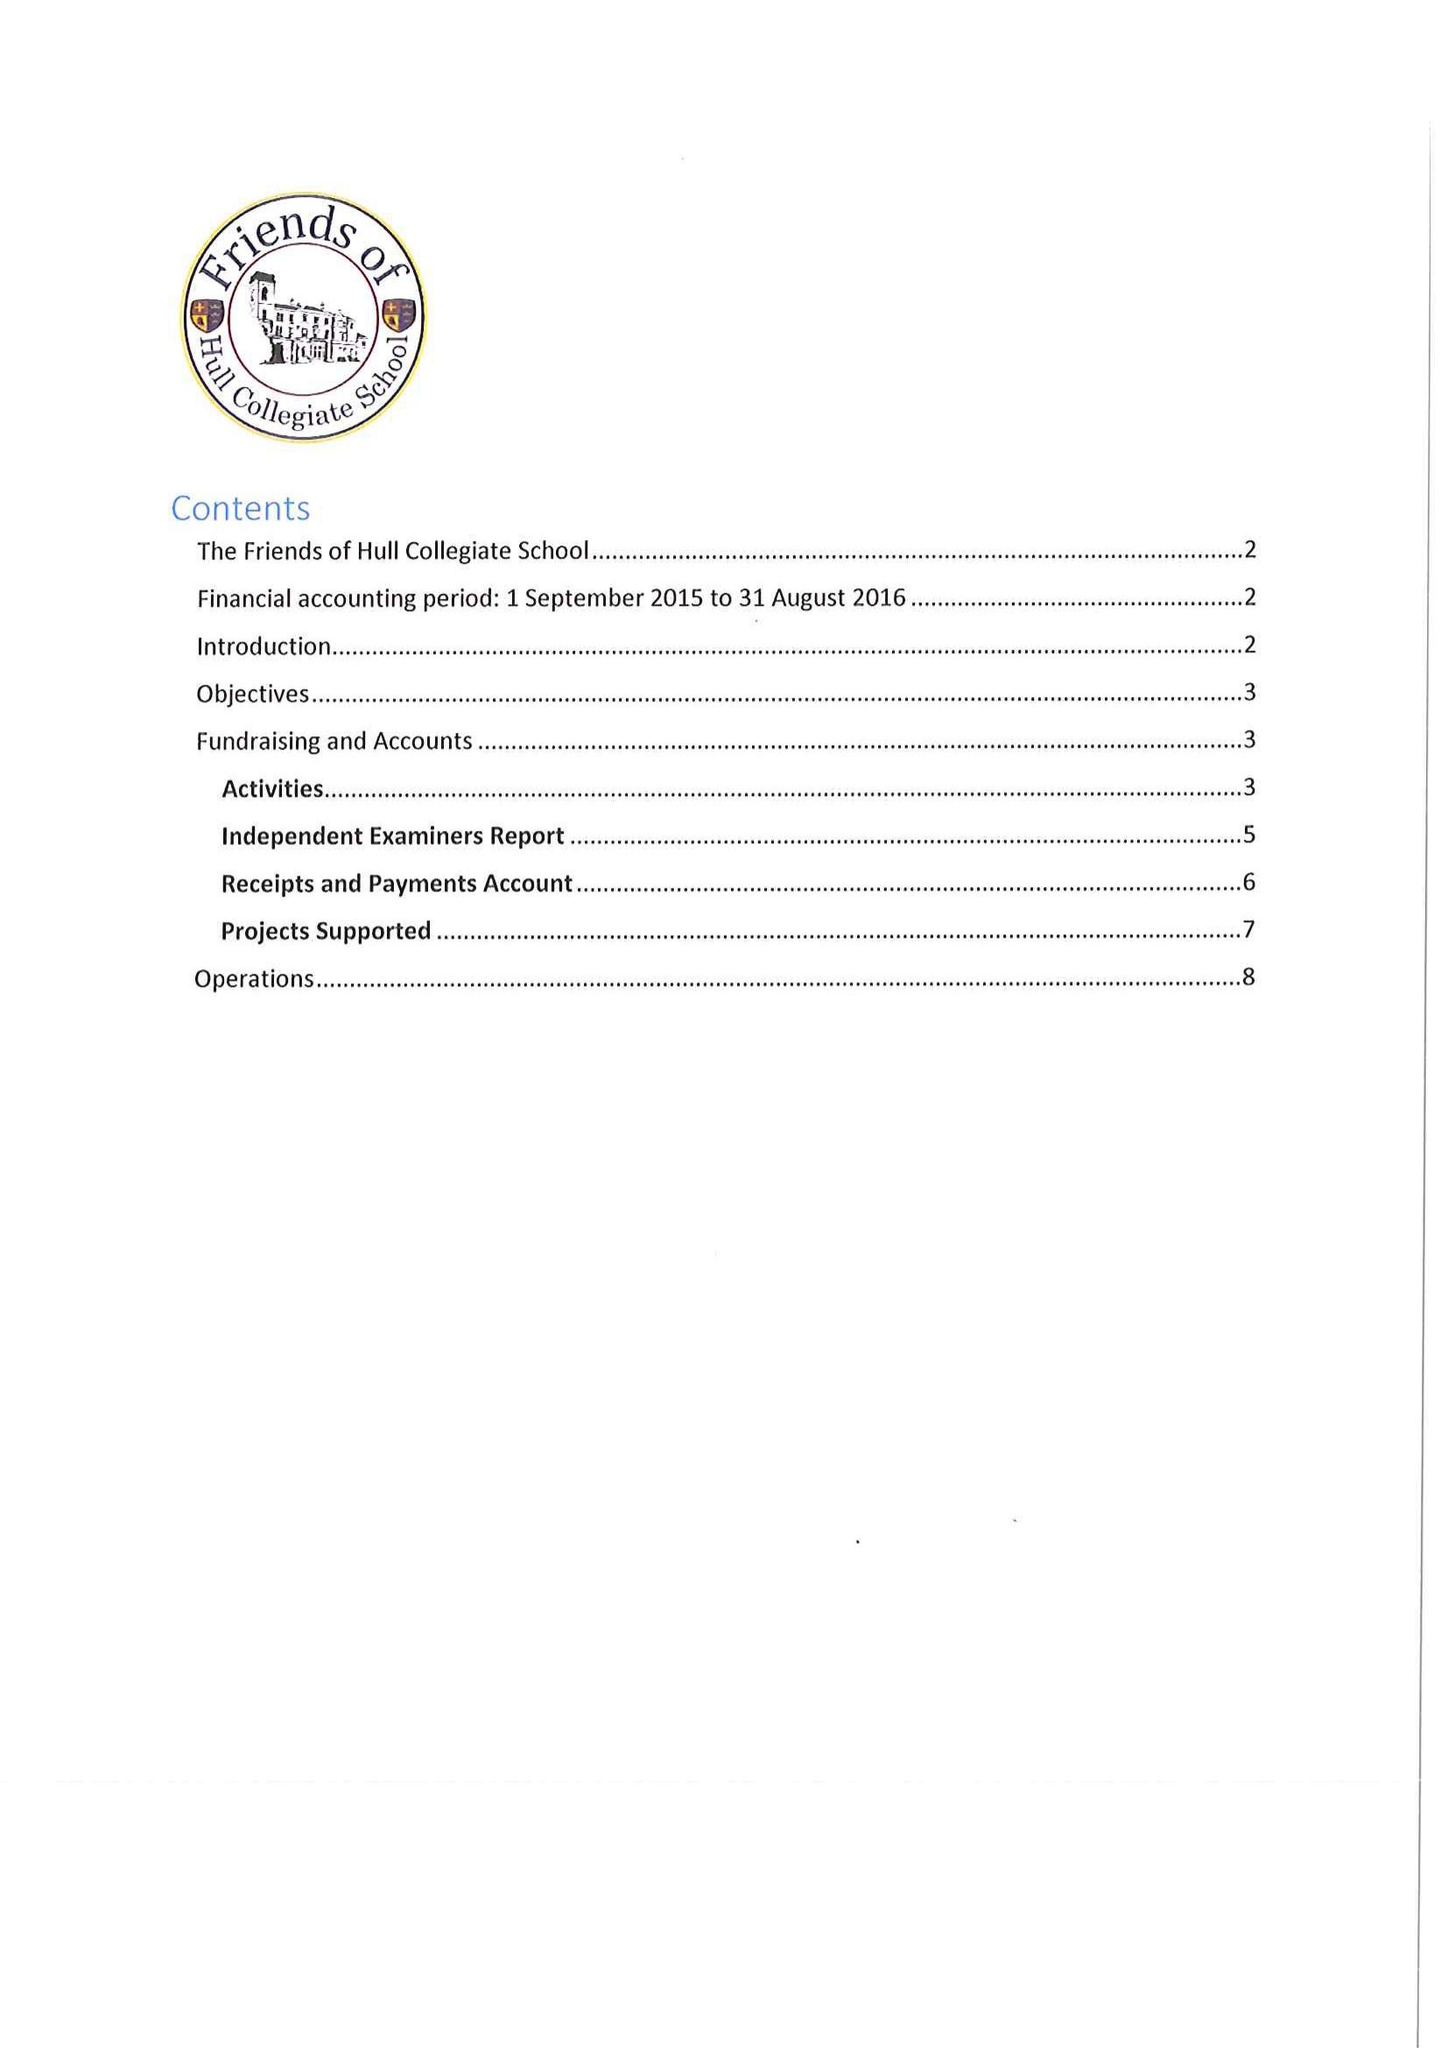What is the value for the charity_name?
Answer the question using a single word or phrase. Friends Of Hull Collegiate School 